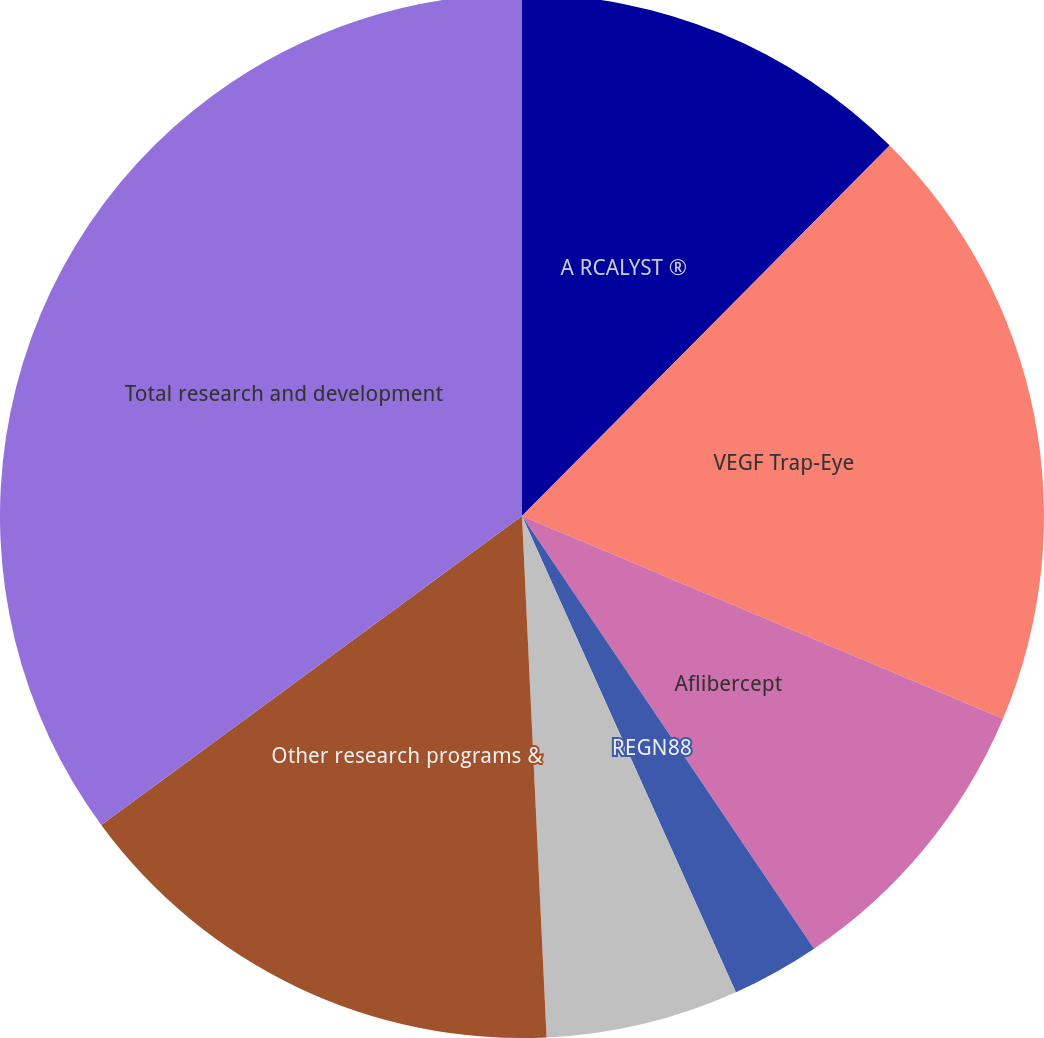Convert chart to OTSL. <chart><loc_0><loc_0><loc_500><loc_500><pie_chart><fcel>A RCALYST ®<fcel>VEGF Trap-Eye<fcel>Aflibercept<fcel>REGN88<fcel>Other antibody candidates in<fcel>Other research programs &<fcel>Total research and development<nl><fcel>12.44%<fcel>18.91%<fcel>9.2%<fcel>2.73%<fcel>5.97%<fcel>15.67%<fcel>35.08%<nl></chart> 